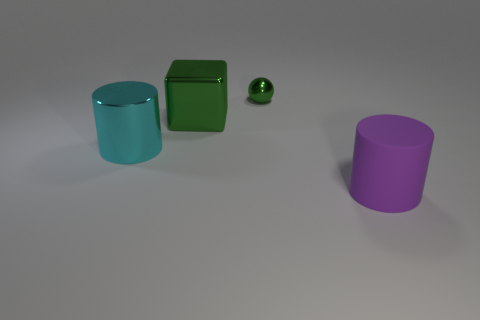Are there any other things that are the same material as the large purple cylinder?
Offer a terse response. No. Is there another big purple block that has the same material as the big cube?
Make the answer very short. No. What number of metal things are either big cyan cylinders or blocks?
Give a very brief answer. 2. The big object in front of the large object to the left of the large green object is what shape?
Offer a terse response. Cylinder. Is the number of spheres that are in front of the big matte thing less than the number of large red rubber balls?
Ensure brevity in your answer.  No. What shape is the small object?
Provide a succinct answer. Sphere. What is the size of the green thing behind the green metal cube?
Your answer should be very brief. Small. The rubber cylinder that is the same size as the green cube is what color?
Your answer should be very brief. Purple. Are there any big things that have the same color as the small metal thing?
Offer a very short reply. Yes. Are there fewer objects that are to the right of the large green shiny cube than metallic things left of the big purple cylinder?
Make the answer very short. Yes. 